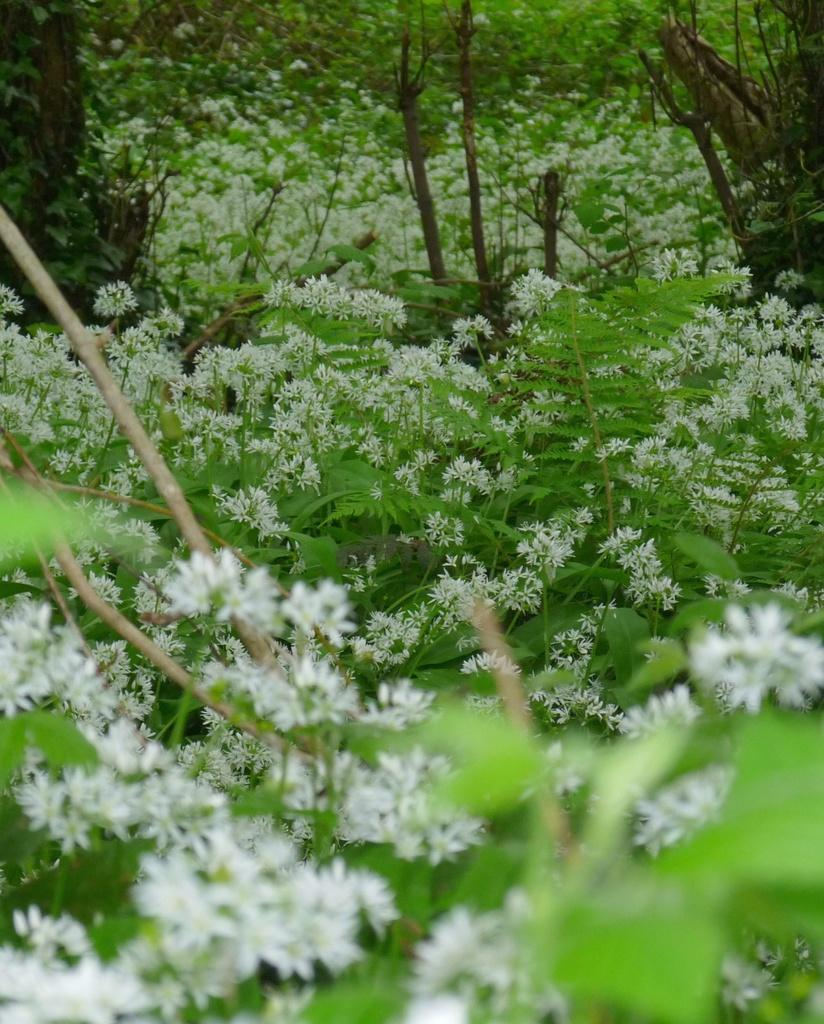What type of vegetation can be seen in the image? There are trees in the image. What is the color of the trees in the image? The trees are green in color. What other natural elements can be seen in the image? There are flowers in the image. What is the color of the flowers in the image? The flowers are white in color. Is the carpenter delivering a parcel to the flowers in the image? There is no carpenter or parcel present in the image; it only features trees and flowers. What time of day is depicted in the image? The time of day is not mentioned or depicted in the image, as it only shows trees and flowers. 